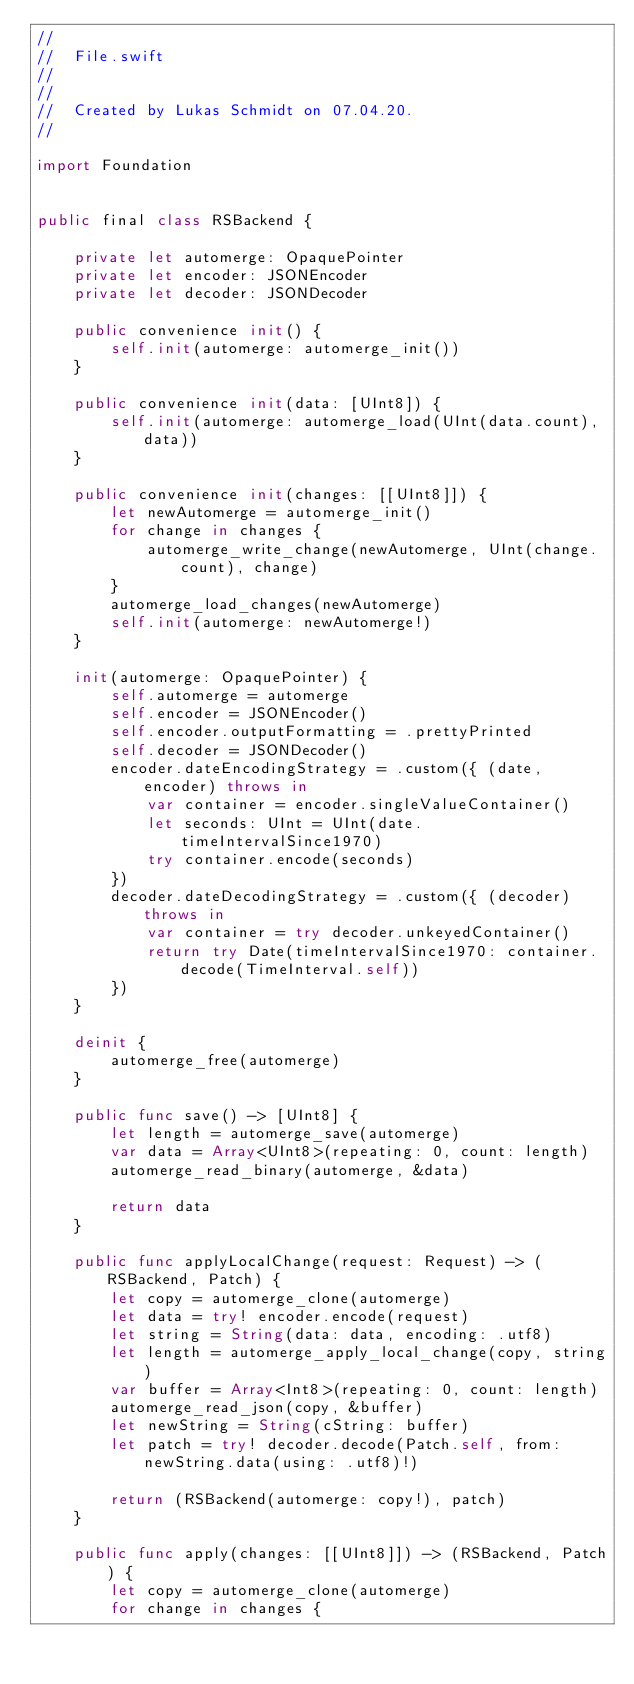Convert code to text. <code><loc_0><loc_0><loc_500><loc_500><_Swift_>//
//  File.swift
//  
//
//  Created by Lukas Schmidt on 07.04.20.
//

import Foundation


public final class RSBackend {

    private let automerge: OpaquePointer
    private let encoder: JSONEncoder
    private let decoder: JSONDecoder

    public convenience init() {
        self.init(automerge: automerge_init())
    }

    public convenience init(data: [UInt8]) {
        self.init(automerge: automerge_load(UInt(data.count), data))
    }

    public convenience init(changes: [[UInt8]]) {
        let newAutomerge = automerge_init()
        for change in changes {
            automerge_write_change(newAutomerge, UInt(change.count), change)
        }
        automerge_load_changes(newAutomerge)
        self.init(automerge: newAutomerge!)
    }

    init(automerge: OpaquePointer) {
        self.automerge = automerge
        self.encoder = JSONEncoder()
        self.encoder.outputFormatting = .prettyPrinted
        self.decoder = JSONDecoder()
        encoder.dateEncodingStrategy = .custom({ (date, encoder) throws in
            var container = encoder.singleValueContainer()
            let seconds: UInt = UInt(date.timeIntervalSince1970)
            try container.encode(seconds)
        })
        decoder.dateDecodingStrategy = .custom({ (decoder) throws in
            var container = try decoder.unkeyedContainer()
            return try Date(timeIntervalSince1970: container.decode(TimeInterval.self))
        })
    }

    deinit {
        automerge_free(automerge)
    }

    public func save() -> [UInt8] {
        let length = automerge_save(automerge)
        var data = Array<UInt8>(repeating: 0, count: length)
        automerge_read_binary(automerge, &data)

        return data
    }

    public func applyLocalChange(request: Request) -> (RSBackend, Patch) {
        let copy = automerge_clone(automerge)
        let data = try! encoder.encode(request)
        let string = String(data: data, encoding: .utf8)
        let length = automerge_apply_local_change(copy, string)
        var buffer = Array<Int8>(repeating: 0, count: length)
        automerge_read_json(copy, &buffer)
        let newString = String(cString: buffer)
        let patch = try! decoder.decode(Patch.self, from: newString.data(using: .utf8)!)

        return (RSBackend(automerge: copy!), patch)
    }

    public func apply(changes: [[UInt8]]) -> (RSBackend, Patch) {
        let copy = automerge_clone(automerge)
        for change in changes {</code> 